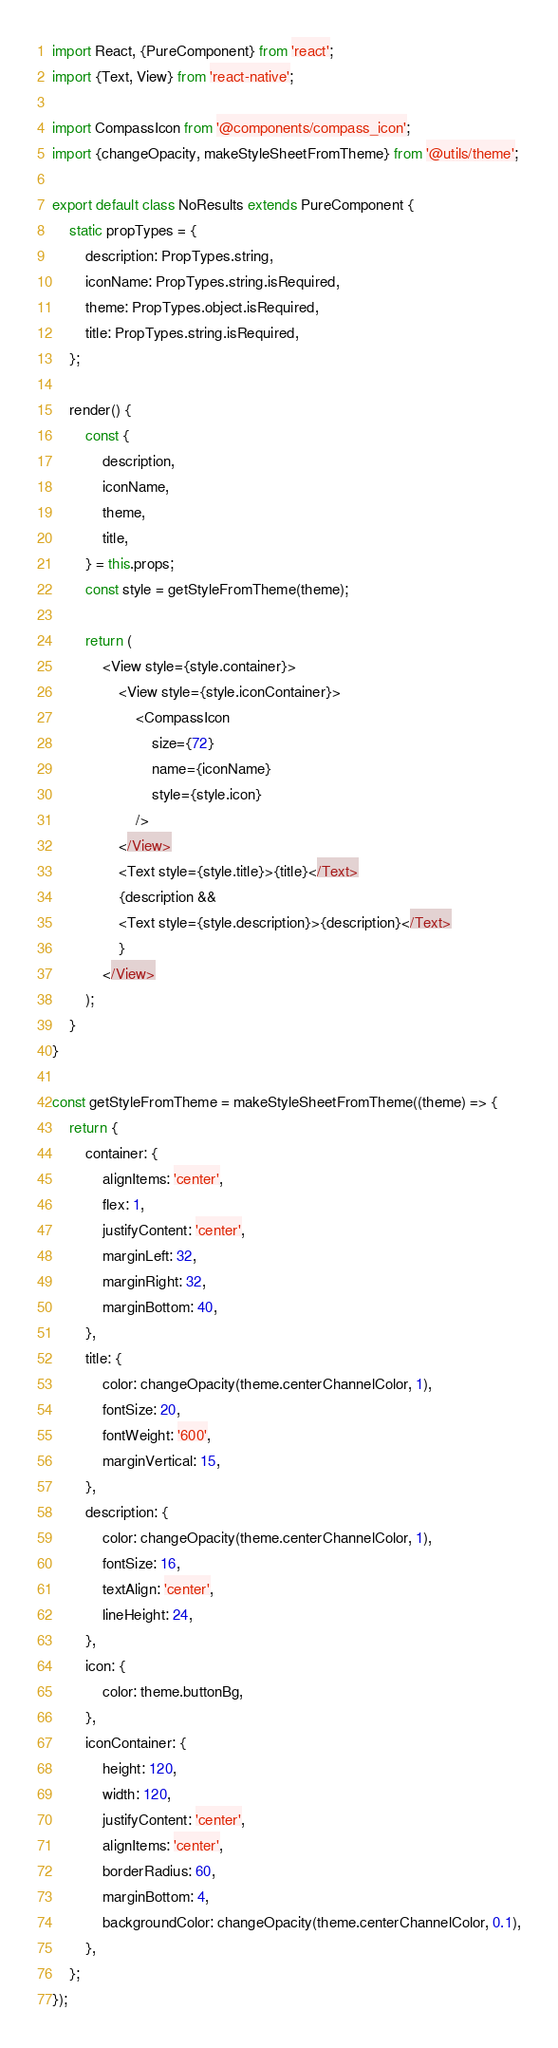<code> <loc_0><loc_0><loc_500><loc_500><_JavaScript_>import React, {PureComponent} from 'react';
import {Text, View} from 'react-native';

import CompassIcon from '@components/compass_icon';
import {changeOpacity, makeStyleSheetFromTheme} from '@utils/theme';

export default class NoResults extends PureComponent {
    static propTypes = {
        description: PropTypes.string,
        iconName: PropTypes.string.isRequired,
        theme: PropTypes.object.isRequired,
        title: PropTypes.string.isRequired,
    };

    render() {
        const {
            description,
            iconName,
            theme,
            title,
        } = this.props;
        const style = getStyleFromTheme(theme);

        return (
            <View style={style.container}>
                <View style={style.iconContainer}>
                    <CompassIcon
                        size={72}
                        name={iconName}
                        style={style.icon}
                    />
                </View>
                <Text style={style.title}>{title}</Text>
                {description &&
                <Text style={style.description}>{description}</Text>
                }
            </View>
        );
    }
}

const getStyleFromTheme = makeStyleSheetFromTheme((theme) => {
    return {
        container: {
            alignItems: 'center',
            flex: 1,
            justifyContent: 'center',
            marginLeft: 32,
            marginRight: 32,
            marginBottom: 40,
        },
        title: {
            color: changeOpacity(theme.centerChannelColor, 1),
            fontSize: 20,
            fontWeight: '600',
            marginVertical: 15,
        },
        description: {
            color: changeOpacity(theme.centerChannelColor, 1),
            fontSize: 16,
            textAlign: 'center',
            lineHeight: 24,
        },
        icon: {
            color: theme.buttonBg,
        },
        iconContainer: {
            height: 120,
            width: 120,
            justifyContent: 'center',
            alignItems: 'center',
            borderRadius: 60,
            marginBottom: 4,
            backgroundColor: changeOpacity(theme.centerChannelColor, 0.1),
        },
    };
});
</code> 